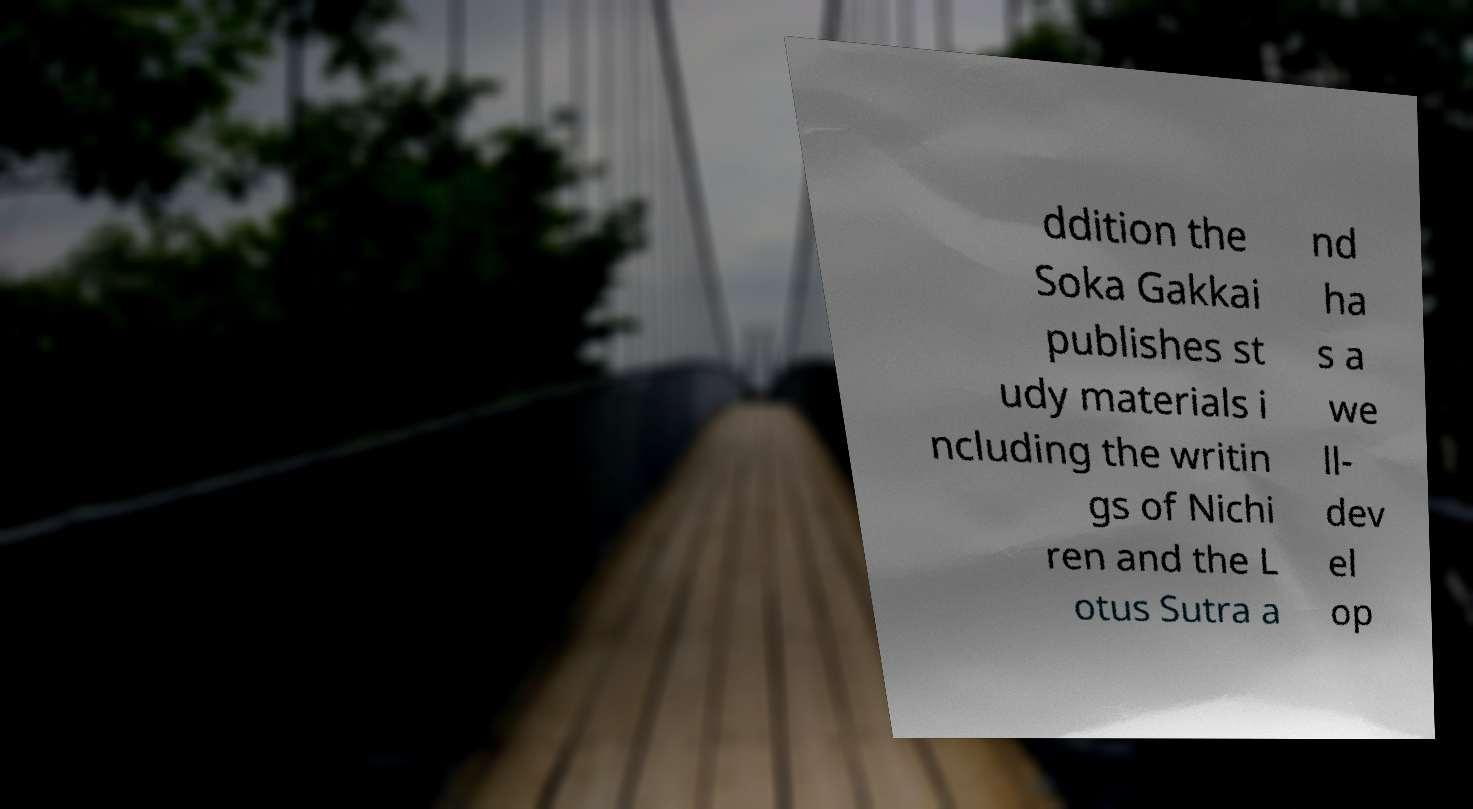Can you read and provide the text displayed in the image?This photo seems to have some interesting text. Can you extract and type it out for me? ddition the Soka Gakkai publishes st udy materials i ncluding the writin gs of Nichi ren and the L otus Sutra a nd ha s a we ll- dev el op 